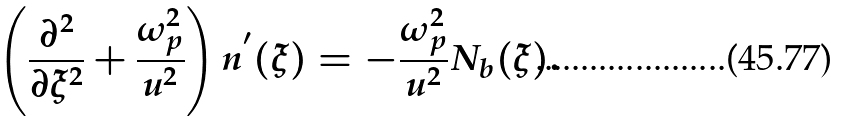Convert formula to latex. <formula><loc_0><loc_0><loc_500><loc_500>\left ( \frac { \partial ^ { 2 } } { \partial \xi ^ { 2 } } + \frac { \omega _ { p } ^ { 2 } } { u ^ { 2 } } \right ) n ^ { ^ { \prime } } ( \xi ) = - \frac { \omega _ { p } ^ { 2 } } { u ^ { 2 } } N _ { b } ( \xi ) .</formula> 